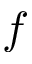<formula> <loc_0><loc_0><loc_500><loc_500>f</formula> 